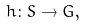<formula> <loc_0><loc_0><loc_500><loc_500>h \colon S \rightarrow G ,</formula> 